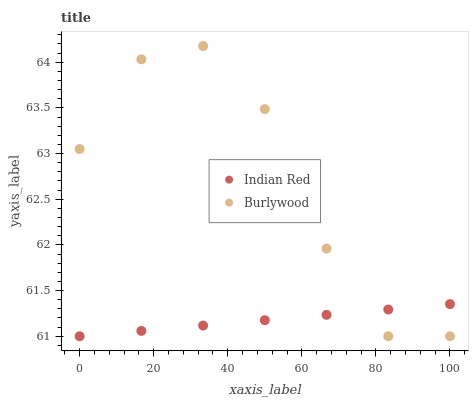Does Indian Red have the minimum area under the curve?
Answer yes or no. Yes. Does Burlywood have the maximum area under the curve?
Answer yes or no. Yes. Does Indian Red have the maximum area under the curve?
Answer yes or no. No. Is Indian Red the smoothest?
Answer yes or no. Yes. Is Burlywood the roughest?
Answer yes or no. Yes. Is Indian Red the roughest?
Answer yes or no. No. Does Burlywood have the lowest value?
Answer yes or no. Yes. Does Burlywood have the highest value?
Answer yes or no. Yes. Does Indian Red have the highest value?
Answer yes or no. No. Does Burlywood intersect Indian Red?
Answer yes or no. Yes. Is Burlywood less than Indian Red?
Answer yes or no. No. Is Burlywood greater than Indian Red?
Answer yes or no. No. 